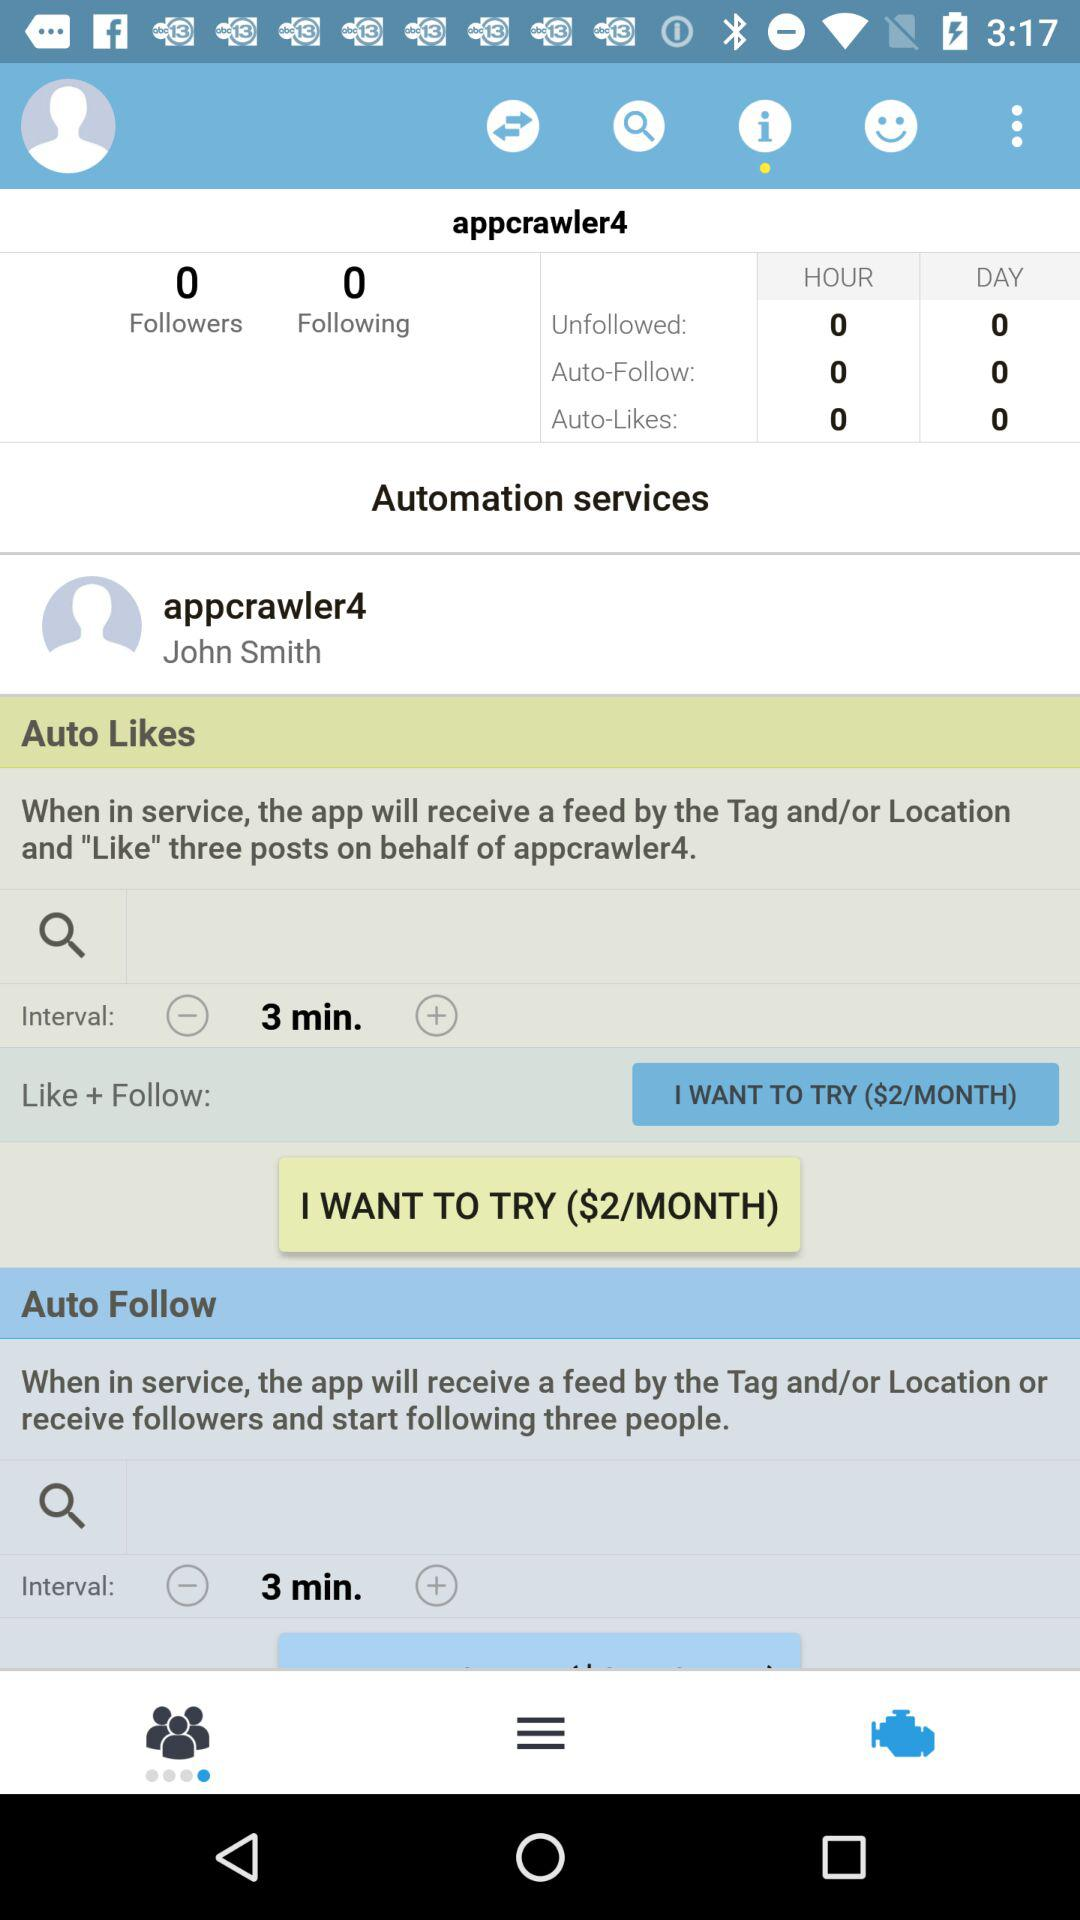How many people does the user follow? The user is following 0 people. 